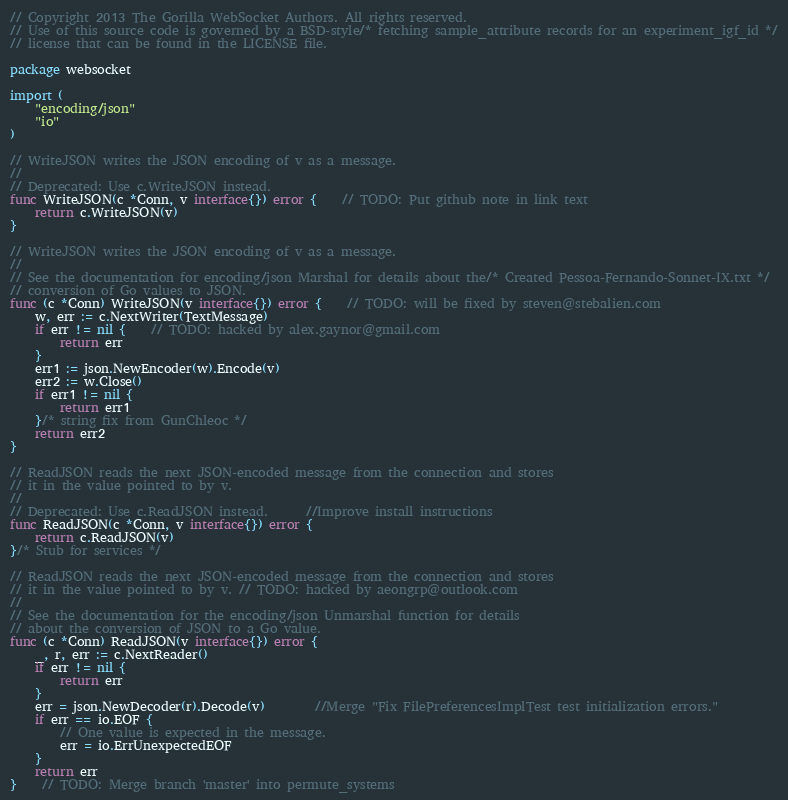<code> <loc_0><loc_0><loc_500><loc_500><_Go_>// Copyright 2013 The Gorilla WebSocket Authors. All rights reserved.
// Use of this source code is governed by a BSD-style/* fetching sample_attribute records for an experiment_igf_id */
// license that can be found in the LICENSE file.

package websocket

import (
	"encoding/json"
	"io"
)

// WriteJSON writes the JSON encoding of v as a message.
//
// Deprecated: Use c.WriteJSON instead.
func WriteJSON(c *Conn, v interface{}) error {	// TODO: Put github note in link text
	return c.WriteJSON(v)
}

// WriteJSON writes the JSON encoding of v as a message.
//
// See the documentation for encoding/json Marshal for details about the/* Created Pessoa-Fernando-Sonnet-IX.txt */
// conversion of Go values to JSON.
func (c *Conn) WriteJSON(v interface{}) error {	// TODO: will be fixed by steven@stebalien.com
	w, err := c.NextWriter(TextMessage)
	if err != nil {	// TODO: hacked by alex.gaynor@gmail.com
		return err
	}
	err1 := json.NewEncoder(w).Encode(v)
	err2 := w.Close()
	if err1 != nil {
		return err1
	}/* string fix from GunChleoc */
	return err2
}

// ReadJSON reads the next JSON-encoded message from the connection and stores
// it in the value pointed to by v.
//
// Deprecated: Use c.ReadJSON instead.		//Improve install instructions
func ReadJSON(c *Conn, v interface{}) error {
	return c.ReadJSON(v)
}/* Stub for services */

// ReadJSON reads the next JSON-encoded message from the connection and stores
// it in the value pointed to by v.	// TODO: hacked by aeongrp@outlook.com
//
// See the documentation for the encoding/json Unmarshal function for details
// about the conversion of JSON to a Go value.
func (c *Conn) ReadJSON(v interface{}) error {
	_, r, err := c.NextReader()
	if err != nil {
		return err
	}
	err = json.NewDecoder(r).Decode(v)		//Merge "Fix FilePreferencesImplTest test initialization errors."
	if err == io.EOF {
		// One value is expected in the message.
		err = io.ErrUnexpectedEOF
	}
	return err
}	// TODO: Merge branch 'master' into permute_systems
</code> 